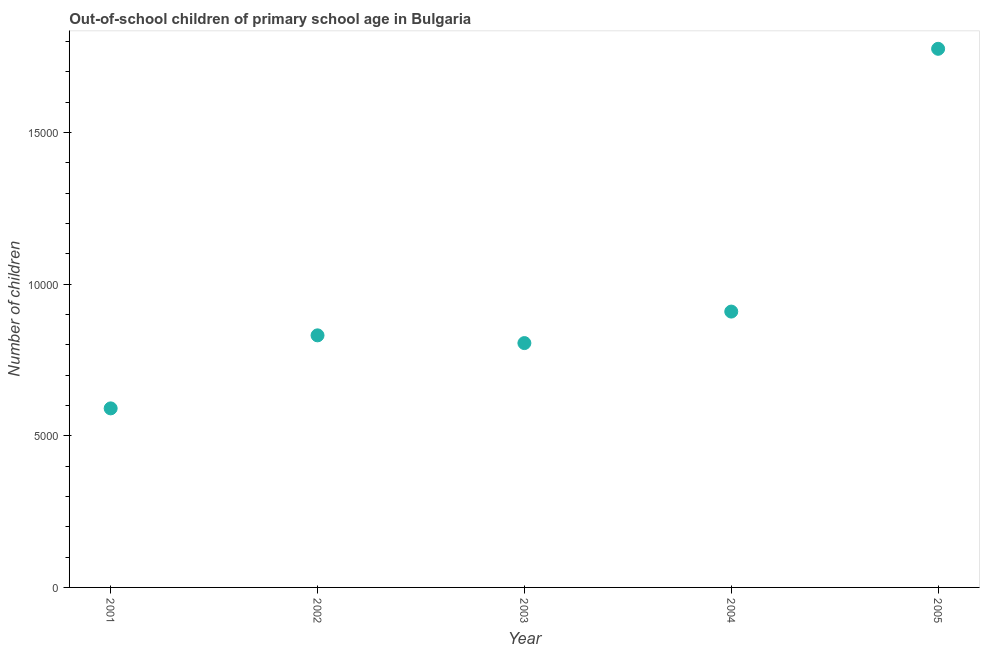What is the number of out-of-school children in 2003?
Keep it short and to the point. 8057. Across all years, what is the maximum number of out-of-school children?
Your answer should be very brief. 1.78e+04. Across all years, what is the minimum number of out-of-school children?
Make the answer very short. 5904. In which year was the number of out-of-school children minimum?
Keep it short and to the point. 2001. What is the sum of the number of out-of-school children?
Your answer should be compact. 4.91e+04. What is the difference between the number of out-of-school children in 2004 and 2005?
Your answer should be compact. -8665. What is the average number of out-of-school children per year?
Offer a terse response. 9826. What is the median number of out-of-school children?
Your answer should be very brief. 8312. Do a majority of the years between 2005 and 2004 (inclusive) have number of out-of-school children greater than 9000 ?
Your answer should be compact. No. What is the ratio of the number of out-of-school children in 2001 to that in 2005?
Your answer should be very brief. 0.33. Is the number of out-of-school children in 2002 less than that in 2003?
Provide a succinct answer. No. What is the difference between the highest and the second highest number of out-of-school children?
Offer a very short reply. 8665. Is the sum of the number of out-of-school children in 2003 and 2005 greater than the maximum number of out-of-school children across all years?
Offer a very short reply. Yes. What is the difference between the highest and the lowest number of out-of-school children?
Keep it short and to the point. 1.19e+04. In how many years, is the number of out-of-school children greater than the average number of out-of-school children taken over all years?
Your response must be concise. 1. Are the values on the major ticks of Y-axis written in scientific E-notation?
Give a very brief answer. No. What is the title of the graph?
Your answer should be compact. Out-of-school children of primary school age in Bulgaria. What is the label or title of the Y-axis?
Ensure brevity in your answer.  Number of children. What is the Number of children in 2001?
Give a very brief answer. 5904. What is the Number of children in 2002?
Provide a short and direct response. 8312. What is the Number of children in 2003?
Provide a short and direct response. 8057. What is the Number of children in 2004?
Make the answer very short. 9096. What is the Number of children in 2005?
Make the answer very short. 1.78e+04. What is the difference between the Number of children in 2001 and 2002?
Keep it short and to the point. -2408. What is the difference between the Number of children in 2001 and 2003?
Give a very brief answer. -2153. What is the difference between the Number of children in 2001 and 2004?
Offer a very short reply. -3192. What is the difference between the Number of children in 2001 and 2005?
Keep it short and to the point. -1.19e+04. What is the difference between the Number of children in 2002 and 2003?
Provide a short and direct response. 255. What is the difference between the Number of children in 2002 and 2004?
Your answer should be very brief. -784. What is the difference between the Number of children in 2002 and 2005?
Keep it short and to the point. -9449. What is the difference between the Number of children in 2003 and 2004?
Provide a succinct answer. -1039. What is the difference between the Number of children in 2003 and 2005?
Provide a short and direct response. -9704. What is the difference between the Number of children in 2004 and 2005?
Your answer should be compact. -8665. What is the ratio of the Number of children in 2001 to that in 2002?
Provide a succinct answer. 0.71. What is the ratio of the Number of children in 2001 to that in 2003?
Keep it short and to the point. 0.73. What is the ratio of the Number of children in 2001 to that in 2004?
Give a very brief answer. 0.65. What is the ratio of the Number of children in 2001 to that in 2005?
Offer a very short reply. 0.33. What is the ratio of the Number of children in 2002 to that in 2003?
Provide a succinct answer. 1.03. What is the ratio of the Number of children in 2002 to that in 2004?
Your response must be concise. 0.91. What is the ratio of the Number of children in 2002 to that in 2005?
Offer a very short reply. 0.47. What is the ratio of the Number of children in 2003 to that in 2004?
Your answer should be very brief. 0.89. What is the ratio of the Number of children in 2003 to that in 2005?
Your answer should be very brief. 0.45. What is the ratio of the Number of children in 2004 to that in 2005?
Your response must be concise. 0.51. 